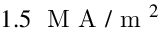<formula> <loc_0><loc_0><loc_500><loc_500>1 . 5 \, M A / m ^ { 2 }</formula> 